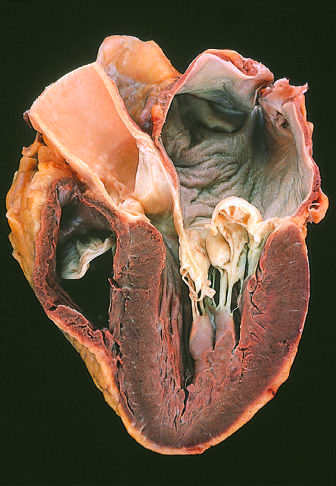s there prominent hooding with prolapse of the posterior mitral leaflet into the left atrium?
Answer the question using a single word or phrase. Yes 